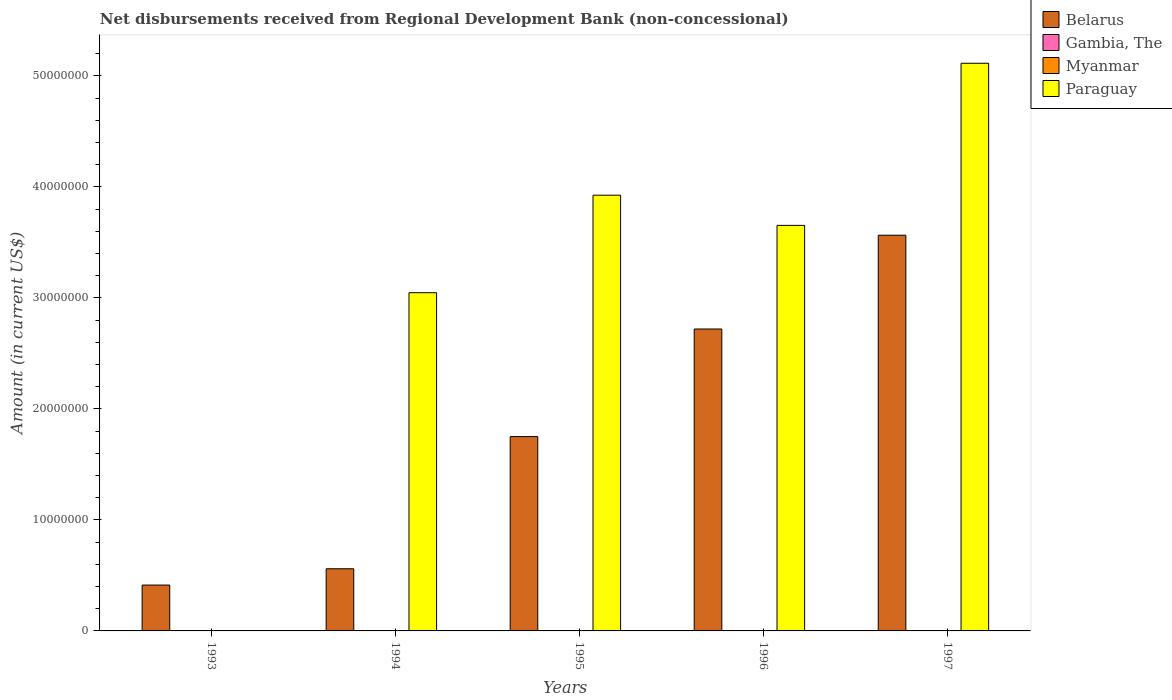Are the number of bars per tick equal to the number of legend labels?
Your answer should be very brief. No. Are the number of bars on each tick of the X-axis equal?
Offer a terse response. No. How many bars are there on the 4th tick from the left?
Your answer should be compact. 2. How many bars are there on the 4th tick from the right?
Give a very brief answer. 2. What is the label of the 3rd group of bars from the left?
Your answer should be very brief. 1995. What is the amount of disbursements received from Regional Development Bank in Belarus in 1993?
Offer a terse response. 4.13e+06. Across all years, what is the maximum amount of disbursements received from Regional Development Bank in Belarus?
Your answer should be compact. 3.56e+07. Across all years, what is the minimum amount of disbursements received from Regional Development Bank in Belarus?
Give a very brief answer. 4.13e+06. What is the total amount of disbursements received from Regional Development Bank in Paraguay in the graph?
Offer a terse response. 1.57e+08. What is the difference between the amount of disbursements received from Regional Development Bank in Belarus in 1993 and that in 1996?
Your answer should be very brief. -2.31e+07. What is the difference between the amount of disbursements received from Regional Development Bank in Belarus in 1994 and the amount of disbursements received from Regional Development Bank in Myanmar in 1995?
Make the answer very short. 5.60e+06. In the year 1997, what is the difference between the amount of disbursements received from Regional Development Bank in Belarus and amount of disbursements received from Regional Development Bank in Paraguay?
Make the answer very short. -1.55e+07. In how many years, is the amount of disbursements received from Regional Development Bank in Gambia, The greater than 50000000 US$?
Keep it short and to the point. 0. What is the ratio of the amount of disbursements received from Regional Development Bank in Belarus in 1996 to that in 1997?
Offer a very short reply. 0.76. Is the amount of disbursements received from Regional Development Bank in Belarus in 1994 less than that in 1995?
Provide a succinct answer. Yes. What is the difference between the highest and the second highest amount of disbursements received from Regional Development Bank in Belarus?
Make the answer very short. 8.45e+06. What is the difference between the highest and the lowest amount of disbursements received from Regional Development Bank in Paraguay?
Your answer should be very brief. 5.11e+07. In how many years, is the amount of disbursements received from Regional Development Bank in Belarus greater than the average amount of disbursements received from Regional Development Bank in Belarus taken over all years?
Provide a succinct answer. 2. Is the sum of the amount of disbursements received from Regional Development Bank in Paraguay in 1995 and 1996 greater than the maximum amount of disbursements received from Regional Development Bank in Gambia, The across all years?
Make the answer very short. Yes. How many bars are there?
Offer a terse response. 9. How many years are there in the graph?
Make the answer very short. 5. Does the graph contain any zero values?
Offer a terse response. Yes. Does the graph contain grids?
Provide a succinct answer. No. Where does the legend appear in the graph?
Provide a succinct answer. Top right. How many legend labels are there?
Provide a succinct answer. 4. How are the legend labels stacked?
Your answer should be compact. Vertical. What is the title of the graph?
Keep it short and to the point. Net disbursements received from Regional Development Bank (non-concessional). Does "Norway" appear as one of the legend labels in the graph?
Your answer should be compact. No. What is the label or title of the X-axis?
Your answer should be compact. Years. What is the Amount (in current US$) in Belarus in 1993?
Your answer should be compact. 4.13e+06. What is the Amount (in current US$) of Gambia, The in 1993?
Your answer should be very brief. 0. What is the Amount (in current US$) in Myanmar in 1993?
Offer a very short reply. 0. What is the Amount (in current US$) of Belarus in 1994?
Provide a succinct answer. 5.60e+06. What is the Amount (in current US$) of Myanmar in 1994?
Give a very brief answer. 0. What is the Amount (in current US$) in Paraguay in 1994?
Provide a succinct answer. 3.05e+07. What is the Amount (in current US$) in Belarus in 1995?
Your answer should be compact. 1.75e+07. What is the Amount (in current US$) in Gambia, The in 1995?
Provide a succinct answer. 0. What is the Amount (in current US$) of Paraguay in 1995?
Give a very brief answer. 3.93e+07. What is the Amount (in current US$) in Belarus in 1996?
Provide a short and direct response. 2.72e+07. What is the Amount (in current US$) in Myanmar in 1996?
Make the answer very short. 0. What is the Amount (in current US$) in Paraguay in 1996?
Ensure brevity in your answer.  3.65e+07. What is the Amount (in current US$) in Belarus in 1997?
Your answer should be compact. 3.56e+07. What is the Amount (in current US$) in Myanmar in 1997?
Make the answer very short. 0. What is the Amount (in current US$) of Paraguay in 1997?
Make the answer very short. 5.11e+07. Across all years, what is the maximum Amount (in current US$) in Belarus?
Provide a succinct answer. 3.56e+07. Across all years, what is the maximum Amount (in current US$) in Paraguay?
Give a very brief answer. 5.11e+07. Across all years, what is the minimum Amount (in current US$) of Belarus?
Offer a very short reply. 4.13e+06. What is the total Amount (in current US$) in Belarus in the graph?
Keep it short and to the point. 9.01e+07. What is the total Amount (in current US$) of Gambia, The in the graph?
Offer a terse response. 0. What is the total Amount (in current US$) of Paraguay in the graph?
Keep it short and to the point. 1.57e+08. What is the difference between the Amount (in current US$) in Belarus in 1993 and that in 1994?
Keep it short and to the point. -1.47e+06. What is the difference between the Amount (in current US$) of Belarus in 1993 and that in 1995?
Give a very brief answer. -1.34e+07. What is the difference between the Amount (in current US$) of Belarus in 1993 and that in 1996?
Your response must be concise. -2.31e+07. What is the difference between the Amount (in current US$) of Belarus in 1993 and that in 1997?
Offer a very short reply. -3.15e+07. What is the difference between the Amount (in current US$) of Belarus in 1994 and that in 1995?
Give a very brief answer. -1.19e+07. What is the difference between the Amount (in current US$) in Paraguay in 1994 and that in 1995?
Make the answer very short. -8.78e+06. What is the difference between the Amount (in current US$) of Belarus in 1994 and that in 1996?
Keep it short and to the point. -2.16e+07. What is the difference between the Amount (in current US$) of Paraguay in 1994 and that in 1996?
Give a very brief answer. -6.06e+06. What is the difference between the Amount (in current US$) of Belarus in 1994 and that in 1997?
Keep it short and to the point. -3.00e+07. What is the difference between the Amount (in current US$) in Paraguay in 1994 and that in 1997?
Offer a very short reply. -2.07e+07. What is the difference between the Amount (in current US$) of Belarus in 1995 and that in 1996?
Your response must be concise. -9.69e+06. What is the difference between the Amount (in current US$) in Paraguay in 1995 and that in 1996?
Give a very brief answer. 2.72e+06. What is the difference between the Amount (in current US$) in Belarus in 1995 and that in 1997?
Make the answer very short. -1.81e+07. What is the difference between the Amount (in current US$) of Paraguay in 1995 and that in 1997?
Provide a short and direct response. -1.19e+07. What is the difference between the Amount (in current US$) in Belarus in 1996 and that in 1997?
Offer a terse response. -8.45e+06. What is the difference between the Amount (in current US$) of Paraguay in 1996 and that in 1997?
Your answer should be compact. -1.46e+07. What is the difference between the Amount (in current US$) of Belarus in 1993 and the Amount (in current US$) of Paraguay in 1994?
Keep it short and to the point. -2.63e+07. What is the difference between the Amount (in current US$) of Belarus in 1993 and the Amount (in current US$) of Paraguay in 1995?
Your answer should be compact. -3.51e+07. What is the difference between the Amount (in current US$) in Belarus in 1993 and the Amount (in current US$) in Paraguay in 1996?
Provide a succinct answer. -3.24e+07. What is the difference between the Amount (in current US$) in Belarus in 1993 and the Amount (in current US$) in Paraguay in 1997?
Your response must be concise. -4.70e+07. What is the difference between the Amount (in current US$) in Belarus in 1994 and the Amount (in current US$) in Paraguay in 1995?
Make the answer very short. -3.37e+07. What is the difference between the Amount (in current US$) of Belarus in 1994 and the Amount (in current US$) of Paraguay in 1996?
Provide a succinct answer. -3.09e+07. What is the difference between the Amount (in current US$) of Belarus in 1994 and the Amount (in current US$) of Paraguay in 1997?
Provide a succinct answer. -4.55e+07. What is the difference between the Amount (in current US$) in Belarus in 1995 and the Amount (in current US$) in Paraguay in 1996?
Your answer should be very brief. -1.90e+07. What is the difference between the Amount (in current US$) of Belarus in 1995 and the Amount (in current US$) of Paraguay in 1997?
Ensure brevity in your answer.  -3.36e+07. What is the difference between the Amount (in current US$) in Belarus in 1996 and the Amount (in current US$) in Paraguay in 1997?
Keep it short and to the point. -2.39e+07. What is the average Amount (in current US$) in Belarus per year?
Your response must be concise. 1.80e+07. What is the average Amount (in current US$) of Gambia, The per year?
Your response must be concise. 0. What is the average Amount (in current US$) in Myanmar per year?
Your answer should be very brief. 0. What is the average Amount (in current US$) of Paraguay per year?
Offer a terse response. 3.15e+07. In the year 1994, what is the difference between the Amount (in current US$) of Belarus and Amount (in current US$) of Paraguay?
Keep it short and to the point. -2.49e+07. In the year 1995, what is the difference between the Amount (in current US$) in Belarus and Amount (in current US$) in Paraguay?
Your response must be concise. -2.17e+07. In the year 1996, what is the difference between the Amount (in current US$) in Belarus and Amount (in current US$) in Paraguay?
Provide a succinct answer. -9.34e+06. In the year 1997, what is the difference between the Amount (in current US$) in Belarus and Amount (in current US$) in Paraguay?
Offer a very short reply. -1.55e+07. What is the ratio of the Amount (in current US$) of Belarus in 1993 to that in 1994?
Keep it short and to the point. 0.74. What is the ratio of the Amount (in current US$) of Belarus in 1993 to that in 1995?
Provide a short and direct response. 0.24. What is the ratio of the Amount (in current US$) in Belarus in 1993 to that in 1996?
Ensure brevity in your answer.  0.15. What is the ratio of the Amount (in current US$) of Belarus in 1993 to that in 1997?
Your response must be concise. 0.12. What is the ratio of the Amount (in current US$) of Belarus in 1994 to that in 1995?
Give a very brief answer. 0.32. What is the ratio of the Amount (in current US$) in Paraguay in 1994 to that in 1995?
Offer a very short reply. 0.78. What is the ratio of the Amount (in current US$) of Belarus in 1994 to that in 1996?
Your answer should be compact. 0.21. What is the ratio of the Amount (in current US$) of Paraguay in 1994 to that in 1996?
Your answer should be very brief. 0.83. What is the ratio of the Amount (in current US$) in Belarus in 1994 to that in 1997?
Keep it short and to the point. 0.16. What is the ratio of the Amount (in current US$) of Paraguay in 1994 to that in 1997?
Ensure brevity in your answer.  0.6. What is the ratio of the Amount (in current US$) in Belarus in 1995 to that in 1996?
Provide a short and direct response. 0.64. What is the ratio of the Amount (in current US$) in Paraguay in 1995 to that in 1996?
Provide a short and direct response. 1.07. What is the ratio of the Amount (in current US$) in Belarus in 1995 to that in 1997?
Offer a terse response. 0.49. What is the ratio of the Amount (in current US$) of Paraguay in 1995 to that in 1997?
Provide a short and direct response. 0.77. What is the ratio of the Amount (in current US$) of Belarus in 1996 to that in 1997?
Provide a short and direct response. 0.76. What is the ratio of the Amount (in current US$) in Paraguay in 1996 to that in 1997?
Offer a very short reply. 0.71. What is the difference between the highest and the second highest Amount (in current US$) in Belarus?
Your answer should be compact. 8.45e+06. What is the difference between the highest and the second highest Amount (in current US$) of Paraguay?
Ensure brevity in your answer.  1.19e+07. What is the difference between the highest and the lowest Amount (in current US$) in Belarus?
Your response must be concise. 3.15e+07. What is the difference between the highest and the lowest Amount (in current US$) of Paraguay?
Offer a very short reply. 5.11e+07. 